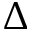Convert formula to latex. <formula><loc_0><loc_0><loc_500><loc_500>\Delta</formula> 